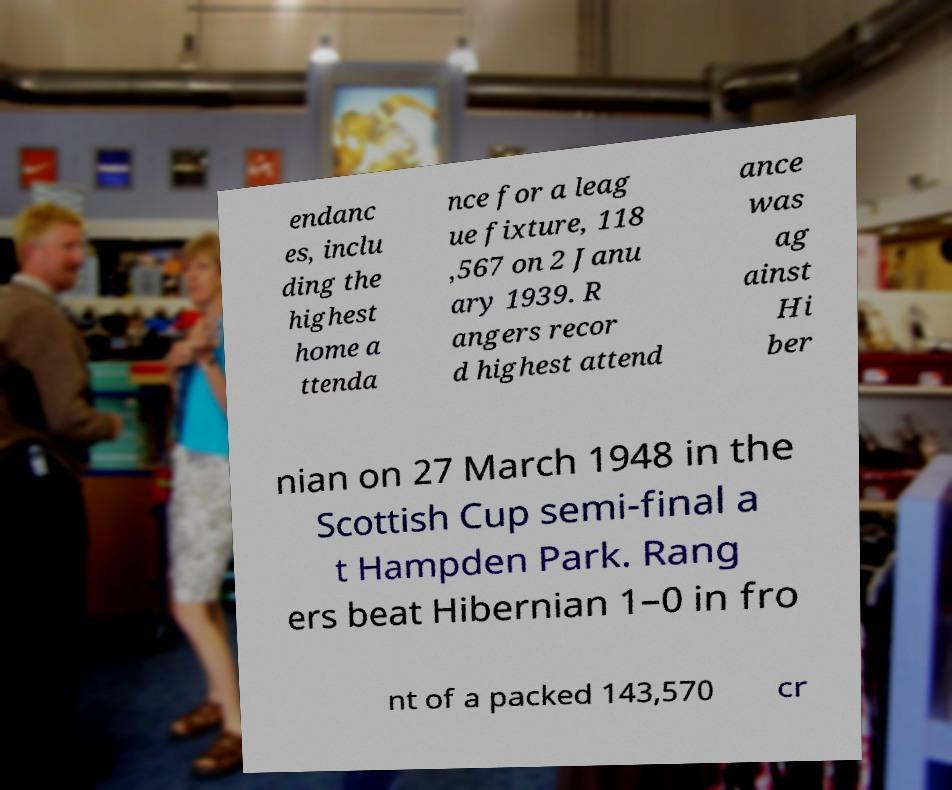There's text embedded in this image that I need extracted. Can you transcribe it verbatim? endanc es, inclu ding the highest home a ttenda nce for a leag ue fixture, 118 ,567 on 2 Janu ary 1939. R angers recor d highest attend ance was ag ainst Hi ber nian on 27 March 1948 in the Scottish Cup semi-final a t Hampden Park. Rang ers beat Hibernian 1–0 in fro nt of a packed 143,570 cr 